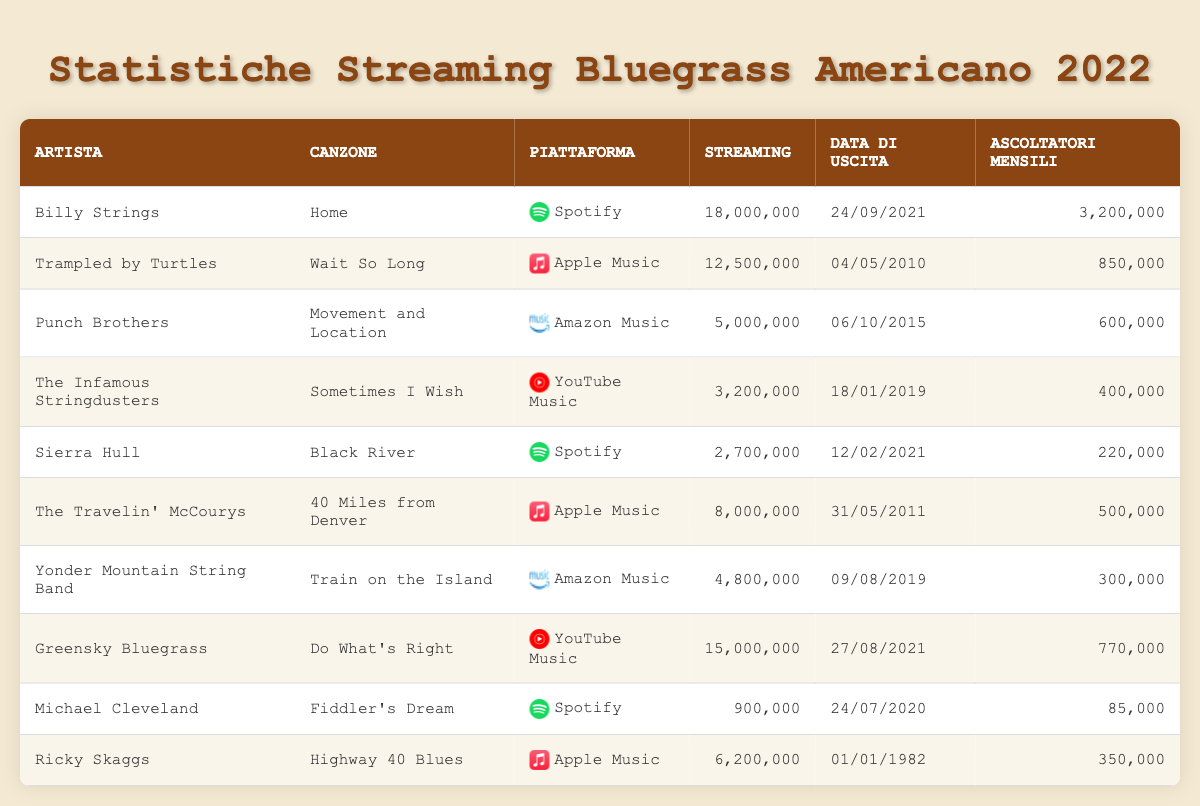What is the most streamed Bluegrass song on Spotify in 2022? The table lists "Home" by Billy Strings with 18,000,000 streams on Spotify, which is the highest number in that category.
Answer: Home Which artist has the highest number of monthly listeners in 2022? By looking at the "Ascoltatori Mensili" column, Billy Strings has 3,200,000 monthly listeners, which is more than any other artist listed.
Answer: Billy Strings What is the total number of streams for the songs listed on YouTube Music? The songs on YouTube Music are "Sometimes I Wish" with 3,200,000 streams and "Do What's Right" with 15,000,000 streams. Summing them gives 3,200,000 + 15,000,000 = 18,200,000.
Answer: 18,200,000 Is there a song from before 2010 with more than 6 million streams? The song "Highway 40 Blues" by Ricky Skaggs, released in 1982, has 6,200,000 streams, which confirms the statement as true.
Answer: Yes How many total streams do the songs from Apple Music have? The songs from Apple Music are "Wait So Long" with 12,500,000 streams, "40 Miles from Denver" with 8,000,000 streams, and "Highway 40 Blues" with 6,200,000 streams. Adding them gives 12,500,000 + 8,000,000 + 6,200,000 = 26,700,000.
Answer: 26,700,000 Which song has the least monthly listeners, and how many does it have? The song "Fiddler's Dream" by Michael Cleveland has the least monthly listeners listed at 85,000.
Answer: Fiddler's Dream, 85,000 What is the average number of streams for songs released after 2018? The songs released after 2018 are "Sometimes I Wish", "Train on the Island", and "Do What's Right" with streams of 3,200,000, 4,800,000, and 15,000,000 respectively. Their total is 3,200,000 + 4,800,000 + 15,000,000 = 23,000,000. Dividing by the 3 songs gives an average of 23,000,000 / 3 = 7,666,667.
Answer: 7,666,667 Does Ricky Skaggs have more monthly listeners than Sierra Hull? Ricky Skaggs has 350,000 monthly listeners, while Sierra Hull has 220,000. Since 350,000 is greater than 220,000, this statement is true.
Answer: Yes How many unique streaming platforms are represented in the table? The platforms listed are Spotify, Apple Music, Amazon Music, and YouTube Music, making for a total of 4 unique platforms represented.
Answer: 4 